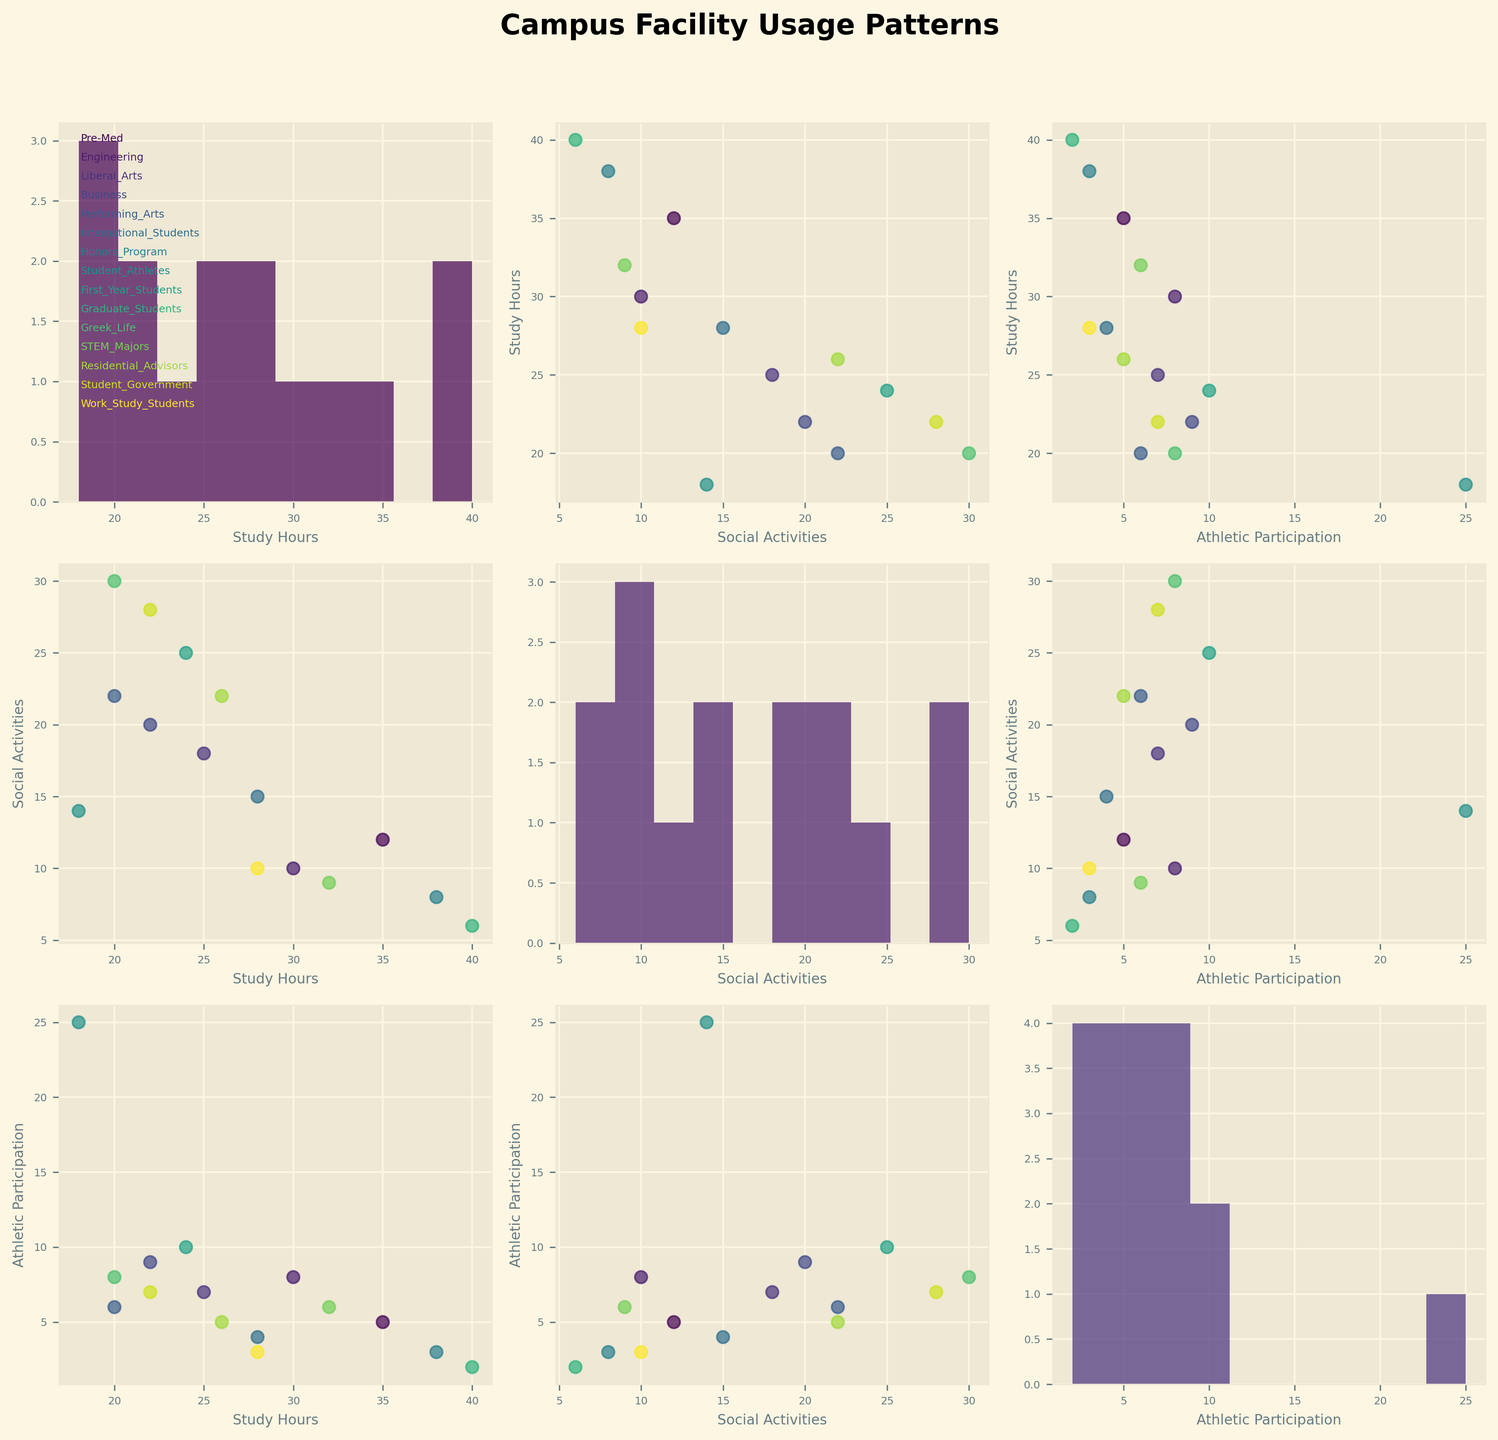How many student groups are represented in the figure? To count the student groups, refer to the list of annotations added in the top-left histogram. Each annotation corresponds to a unique student group.
Answer: 15 What is the title of the figure? The title is typically located at the top of the figure and provides an overview of the figure's content.
Answer: Campus Facility Usage Patterns Which student group has the highest average study hours? Identify the group with the highest value in the "Study Hours" histogram or plot. The tallest bar or the rightmost point in the scatterplots involving Study_Hours indicates the highest value.
Answer: Graduate Students Among Study_Hours, Social_Activities, and Athletic_Participation, which pair has the most positive correlation? In the scatterplot matrix, look for the pair that shows an upward trend in the corresponding scatterplot. The steepest upward trend indicates the strongest positive correlation.
Answer: Social Activities and Athletic Participation Which student group participates the least in athletics? Look at the lowest values in the "Athletic Participation" histograms or scatterplots involving Athletic_Participation to find the student group with the minimum value.
Answer: Graduate Students How do "Study Hours" and "Social Activities" compare for Honors Program and Business students? Locate the respective data points for Honors Program and Business students in the scatterplot of Study_Hours vs Social_Activities. Compare their x (Social_Activities) and y (Study_Hours) values. Honors Program: Study Hours = 38, Social Activities = 8; Business students: Study Hours = 22, Social Activities = 20.
Answer: Honors Program: more Study Hours, fewer Social Activities In which histogram do the student groups appear most evenly distributed? Examine the histograms to see where the bars are roughly equal in height. This indicates an even distribution of values among student groups.
Answer: Athletic Participation Which two student groups have similar patterns in "Social Activities" and "Athletic Participation"? Find pairs of student groups that have data points close together in the Social_Activities vs Athletic_Participation scatterplot.
Answer: Liberal Arts and Student Government What is the range of Study Hours for the student groups? Identify the minimum and maximum values in the Study_Hours histogram. Subtract the minimum value from the maximum value to get the range.
Answer: 40 - 18 = 22 Which student group has a higher athletic participation: First Year Students or Greek Life? Locate the data points for First Year Students and Greek Life in scatterplots involving Athletic_Participation and compare their values.
Answer: Greek Life 